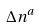Convert formula to latex. <formula><loc_0><loc_0><loc_500><loc_500>\Delta n ^ { a }</formula> 